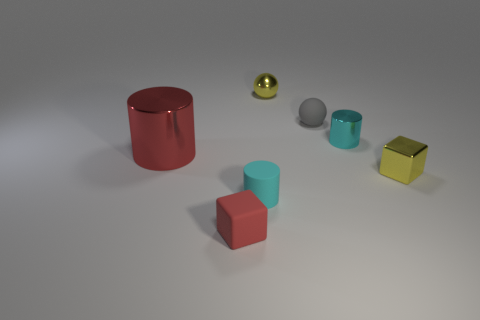Is the shape of the small red object the same as the small matte thing that is to the right of the tiny cyan matte cylinder?
Keep it short and to the point. No. Is the number of small gray balls that are behind the small yellow sphere less than the number of big blue cylinders?
Offer a very short reply. No. Are there any cyan objects left of the big metal object?
Provide a succinct answer. No. Is there a tiny thing of the same shape as the big red metallic thing?
Keep it short and to the point. Yes. There is a red object that is the same size as the cyan metallic cylinder; what is its shape?
Ensure brevity in your answer.  Cube. How many objects are either small cyan cylinders that are to the right of the large metallic object or small brown spheres?
Make the answer very short. 2. Is the large metal cylinder the same color as the tiny metal cylinder?
Ensure brevity in your answer.  No. There is a metal cylinder behind the big red metallic cylinder; how big is it?
Provide a succinct answer. Small. Is there a cyan cylinder that has the same size as the red shiny cylinder?
Provide a short and direct response. No. Does the shiny thing that is on the left side of the red matte object have the same size as the cyan metallic cylinder?
Keep it short and to the point. No. 